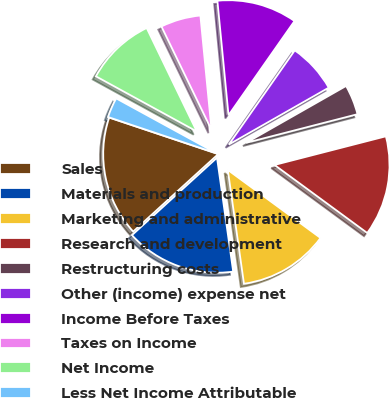Convert chart. <chart><loc_0><loc_0><loc_500><loc_500><pie_chart><fcel>Sales<fcel>Materials and production<fcel>Marketing and administrative<fcel>Research and development<fcel>Restructuring costs<fcel>Other (income) expense net<fcel>Income Before Taxes<fcel>Taxes on Income<fcel>Net Income<fcel>Less Net Income Attributable<nl><fcel>16.9%<fcel>15.49%<fcel>12.68%<fcel>14.08%<fcel>4.23%<fcel>7.04%<fcel>11.27%<fcel>5.63%<fcel>9.86%<fcel>2.82%<nl></chart> 